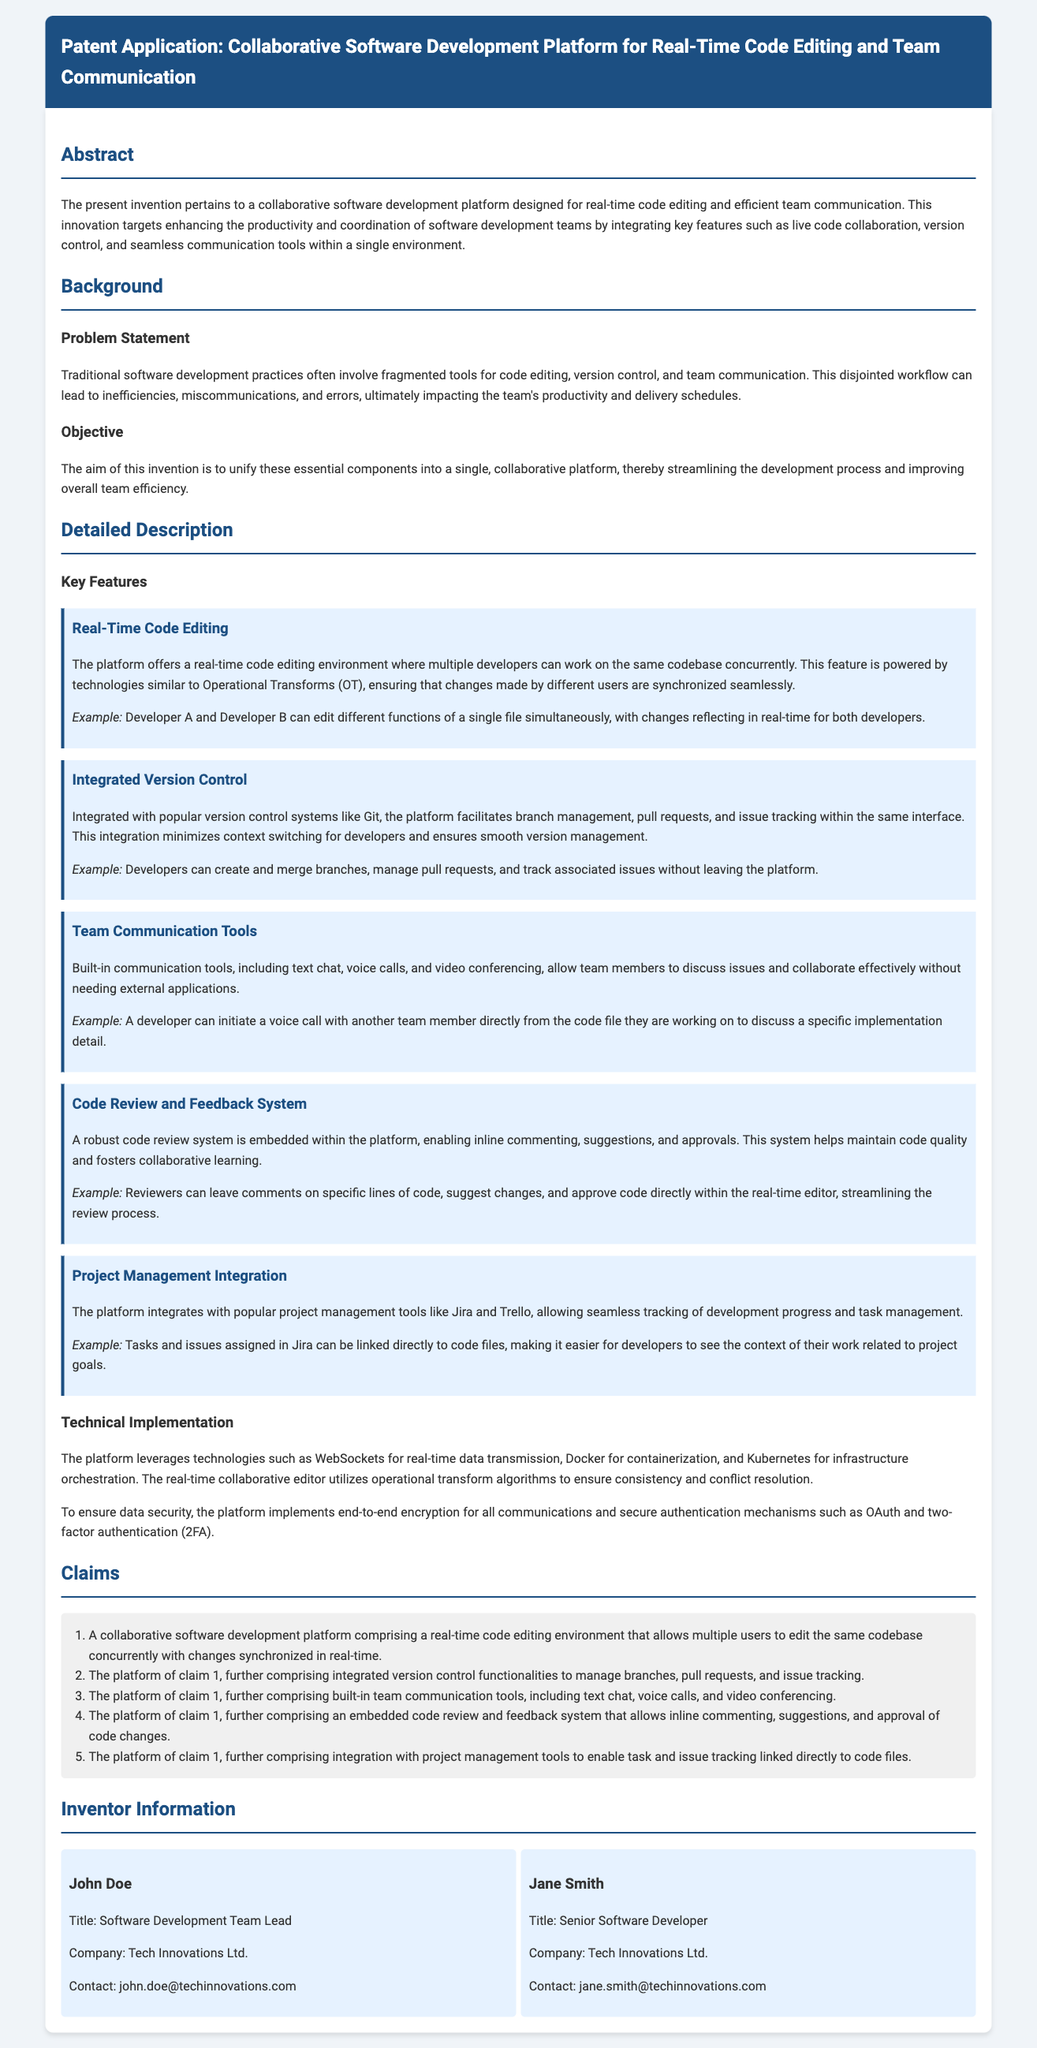What is the title of the patent application? The title of the patent application is explicitly mentioned at the beginning of the document.
Answer: Collaborative Software Development Platform for Real-Time Code Editing and Team Communication What is the main objective of the invention? The objective is to unify essential components into a single platform to streamline the development process.
Answer: Streamlining the development process Which feature allows multiple developers to work simultaneously? This feature is mentioned in the detailed description section, under key features.
Answer: Real-Time Code Editing What technology is used for real-time data transmission? The technology used for real-time data transmission is specified in the technical implementation section.
Answer: WebSockets Who is the software development team lead mentioned in the document? The document provides specific names and titles within the inventor information section.
Answer: John Doe How many claims are listed in the patent application? The number of claims can be counted from the claims section of the document.
Answer: Five Which project management tools does the platform integrate with? The integration with project management tools is highlighted in the key features section of the document.
Answer: Jira and Trello What security measures are implemented for data security? Security measures are detailed in the technical implementation section of the document.
Answer: End-to-end encryption and OAuth What does the embedded code review system allow? The functionality of the code review system is described in the key features section.
Answer: Inline commenting and approvals 